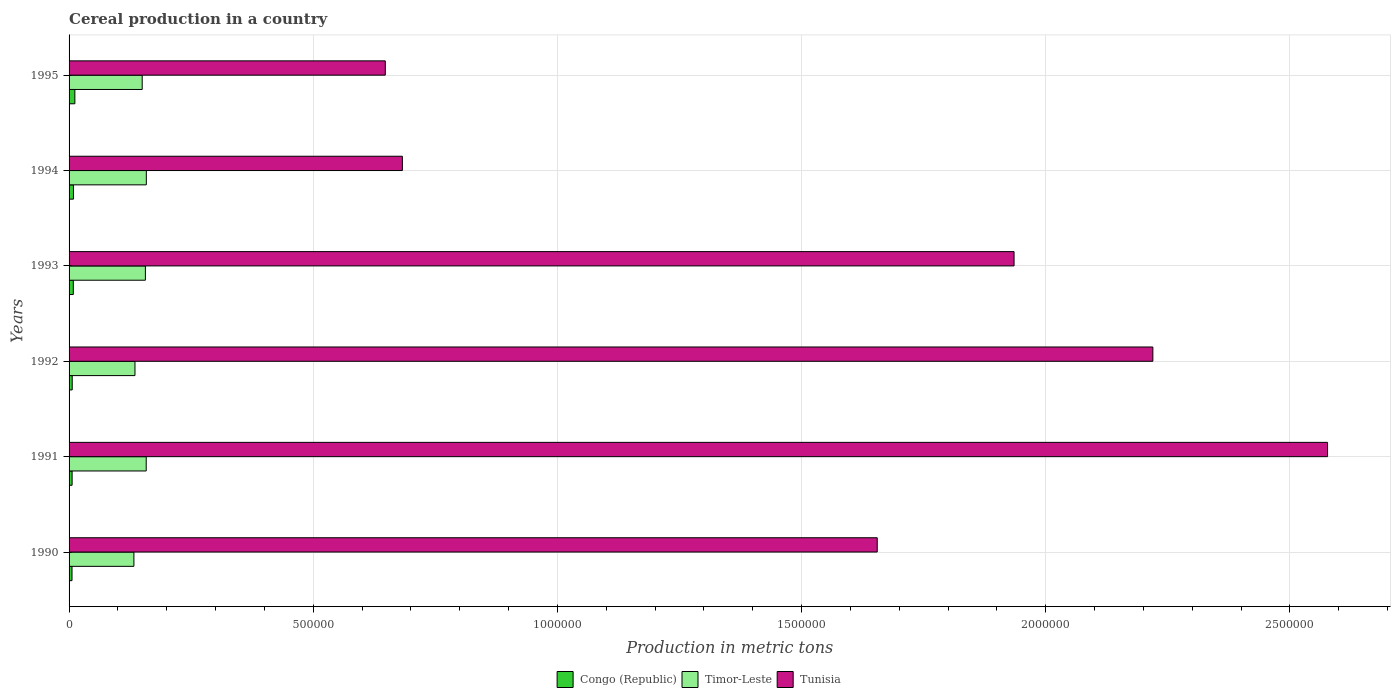Are the number of bars per tick equal to the number of legend labels?
Make the answer very short. Yes. Are the number of bars on each tick of the Y-axis equal?
Make the answer very short. Yes. How many bars are there on the 1st tick from the bottom?
Provide a short and direct response. 3. What is the label of the 6th group of bars from the top?
Ensure brevity in your answer.  1990. What is the total cereal production in Congo (Republic) in 1993?
Give a very brief answer. 8663. Across all years, what is the maximum total cereal production in Timor-Leste?
Your answer should be compact. 1.58e+05. Across all years, what is the minimum total cereal production in Congo (Republic)?
Make the answer very short. 6014. In which year was the total cereal production in Timor-Leste maximum?
Provide a succinct answer. 1994. In which year was the total cereal production in Timor-Leste minimum?
Give a very brief answer. 1990. What is the total total cereal production in Timor-Leste in the graph?
Give a very brief answer. 8.90e+05. What is the difference between the total cereal production in Timor-Leste in 1990 and that in 1991?
Make the answer very short. -2.52e+04. What is the difference between the total cereal production in Timor-Leste in 1992 and the total cereal production in Tunisia in 1995?
Make the answer very short. -5.13e+05. What is the average total cereal production in Timor-Leste per year?
Keep it short and to the point. 1.48e+05. In the year 1992, what is the difference between the total cereal production in Tunisia and total cereal production in Timor-Leste?
Your response must be concise. 2.08e+06. In how many years, is the total cereal production in Congo (Republic) greater than 400000 metric tons?
Ensure brevity in your answer.  0. What is the ratio of the total cereal production in Congo (Republic) in 1991 to that in 1994?
Offer a terse response. 0.69. Is the difference between the total cereal production in Tunisia in 1990 and 1991 greater than the difference between the total cereal production in Timor-Leste in 1990 and 1991?
Offer a terse response. No. What is the difference between the highest and the second highest total cereal production in Tunisia?
Provide a short and direct response. 3.58e+05. What is the difference between the highest and the lowest total cereal production in Tunisia?
Provide a short and direct response. 1.93e+06. Is the sum of the total cereal production in Congo (Republic) in 1990 and 1995 greater than the maximum total cereal production in Tunisia across all years?
Provide a succinct answer. No. What does the 1st bar from the top in 1993 represents?
Offer a very short reply. Tunisia. What does the 3rd bar from the bottom in 1990 represents?
Your response must be concise. Tunisia. Are the values on the major ticks of X-axis written in scientific E-notation?
Keep it short and to the point. No. Does the graph contain any zero values?
Your answer should be compact. No. Does the graph contain grids?
Make the answer very short. Yes. How are the legend labels stacked?
Offer a terse response. Horizontal. What is the title of the graph?
Ensure brevity in your answer.  Cereal production in a country. Does "Tonga" appear as one of the legend labels in the graph?
Provide a succinct answer. No. What is the label or title of the X-axis?
Ensure brevity in your answer.  Production in metric tons. What is the Production in metric tons of Congo (Republic) in 1990?
Keep it short and to the point. 6014. What is the Production in metric tons of Timor-Leste in 1990?
Provide a short and direct response. 1.33e+05. What is the Production in metric tons of Tunisia in 1990?
Provide a succinct answer. 1.65e+06. What is the Production in metric tons of Congo (Republic) in 1991?
Your answer should be compact. 6225. What is the Production in metric tons in Timor-Leste in 1991?
Provide a succinct answer. 1.58e+05. What is the Production in metric tons of Tunisia in 1991?
Give a very brief answer. 2.58e+06. What is the Production in metric tons of Congo (Republic) in 1992?
Your response must be concise. 6442. What is the Production in metric tons of Timor-Leste in 1992?
Keep it short and to the point. 1.35e+05. What is the Production in metric tons in Tunisia in 1992?
Make the answer very short. 2.22e+06. What is the Production in metric tons in Congo (Republic) in 1993?
Provide a short and direct response. 8663. What is the Production in metric tons of Timor-Leste in 1993?
Make the answer very short. 1.56e+05. What is the Production in metric tons of Tunisia in 1993?
Offer a very short reply. 1.94e+06. What is the Production in metric tons in Congo (Republic) in 1994?
Provide a succinct answer. 8967. What is the Production in metric tons in Timor-Leste in 1994?
Offer a very short reply. 1.58e+05. What is the Production in metric tons of Tunisia in 1994?
Ensure brevity in your answer.  6.82e+05. What is the Production in metric tons in Congo (Republic) in 1995?
Make the answer very short. 1.18e+04. What is the Production in metric tons in Timor-Leste in 1995?
Your answer should be very brief. 1.50e+05. What is the Production in metric tons in Tunisia in 1995?
Provide a short and direct response. 6.48e+05. Across all years, what is the maximum Production in metric tons in Congo (Republic)?
Offer a terse response. 1.18e+04. Across all years, what is the maximum Production in metric tons in Timor-Leste?
Make the answer very short. 1.58e+05. Across all years, what is the maximum Production in metric tons in Tunisia?
Your response must be concise. 2.58e+06. Across all years, what is the minimum Production in metric tons of Congo (Republic)?
Provide a succinct answer. 6014. Across all years, what is the minimum Production in metric tons of Timor-Leste?
Your answer should be very brief. 1.33e+05. Across all years, what is the minimum Production in metric tons of Tunisia?
Offer a very short reply. 6.48e+05. What is the total Production in metric tons of Congo (Republic) in the graph?
Provide a succinct answer. 4.82e+04. What is the total Production in metric tons of Timor-Leste in the graph?
Your answer should be very brief. 8.90e+05. What is the total Production in metric tons of Tunisia in the graph?
Give a very brief answer. 9.72e+06. What is the difference between the Production in metric tons of Congo (Republic) in 1990 and that in 1991?
Offer a terse response. -211. What is the difference between the Production in metric tons of Timor-Leste in 1990 and that in 1991?
Your answer should be compact. -2.52e+04. What is the difference between the Production in metric tons in Tunisia in 1990 and that in 1991?
Ensure brevity in your answer.  -9.22e+05. What is the difference between the Production in metric tons in Congo (Republic) in 1990 and that in 1992?
Offer a terse response. -428. What is the difference between the Production in metric tons in Timor-Leste in 1990 and that in 1992?
Ensure brevity in your answer.  -2167. What is the difference between the Production in metric tons of Tunisia in 1990 and that in 1992?
Your answer should be compact. -5.64e+05. What is the difference between the Production in metric tons in Congo (Republic) in 1990 and that in 1993?
Your response must be concise. -2649. What is the difference between the Production in metric tons in Timor-Leste in 1990 and that in 1993?
Provide a succinct answer. -2.35e+04. What is the difference between the Production in metric tons of Tunisia in 1990 and that in 1993?
Offer a very short reply. -2.80e+05. What is the difference between the Production in metric tons of Congo (Republic) in 1990 and that in 1994?
Your answer should be compact. -2953. What is the difference between the Production in metric tons in Timor-Leste in 1990 and that in 1994?
Make the answer very short. -2.54e+04. What is the difference between the Production in metric tons of Tunisia in 1990 and that in 1994?
Your answer should be very brief. 9.72e+05. What is the difference between the Production in metric tons in Congo (Republic) in 1990 and that in 1995?
Ensure brevity in your answer.  -5835. What is the difference between the Production in metric tons in Timor-Leste in 1990 and that in 1995?
Give a very brief answer. -1.70e+04. What is the difference between the Production in metric tons in Tunisia in 1990 and that in 1995?
Your answer should be very brief. 1.01e+06. What is the difference between the Production in metric tons of Congo (Republic) in 1991 and that in 1992?
Your answer should be very brief. -217. What is the difference between the Production in metric tons of Timor-Leste in 1991 and that in 1992?
Give a very brief answer. 2.30e+04. What is the difference between the Production in metric tons in Tunisia in 1991 and that in 1992?
Give a very brief answer. 3.58e+05. What is the difference between the Production in metric tons of Congo (Republic) in 1991 and that in 1993?
Provide a succinct answer. -2438. What is the difference between the Production in metric tons in Timor-Leste in 1991 and that in 1993?
Provide a short and direct response. 1677. What is the difference between the Production in metric tons of Tunisia in 1991 and that in 1993?
Keep it short and to the point. 6.42e+05. What is the difference between the Production in metric tons of Congo (Republic) in 1991 and that in 1994?
Provide a succinct answer. -2742. What is the difference between the Production in metric tons of Timor-Leste in 1991 and that in 1994?
Your answer should be very brief. -234. What is the difference between the Production in metric tons of Tunisia in 1991 and that in 1994?
Your response must be concise. 1.89e+06. What is the difference between the Production in metric tons of Congo (Republic) in 1991 and that in 1995?
Offer a very short reply. -5624. What is the difference between the Production in metric tons in Timor-Leste in 1991 and that in 1995?
Your answer should be compact. 8231. What is the difference between the Production in metric tons of Tunisia in 1991 and that in 1995?
Offer a very short reply. 1.93e+06. What is the difference between the Production in metric tons in Congo (Republic) in 1992 and that in 1993?
Offer a terse response. -2221. What is the difference between the Production in metric tons in Timor-Leste in 1992 and that in 1993?
Give a very brief answer. -2.14e+04. What is the difference between the Production in metric tons of Tunisia in 1992 and that in 1993?
Ensure brevity in your answer.  2.84e+05. What is the difference between the Production in metric tons in Congo (Republic) in 1992 and that in 1994?
Make the answer very short. -2525. What is the difference between the Production in metric tons in Timor-Leste in 1992 and that in 1994?
Your response must be concise. -2.33e+04. What is the difference between the Production in metric tons of Tunisia in 1992 and that in 1994?
Make the answer very short. 1.54e+06. What is the difference between the Production in metric tons in Congo (Republic) in 1992 and that in 1995?
Your response must be concise. -5407. What is the difference between the Production in metric tons of Timor-Leste in 1992 and that in 1995?
Keep it short and to the point. -1.48e+04. What is the difference between the Production in metric tons in Tunisia in 1992 and that in 1995?
Provide a short and direct response. 1.57e+06. What is the difference between the Production in metric tons in Congo (Republic) in 1993 and that in 1994?
Offer a terse response. -304. What is the difference between the Production in metric tons of Timor-Leste in 1993 and that in 1994?
Give a very brief answer. -1911. What is the difference between the Production in metric tons in Tunisia in 1993 and that in 1994?
Keep it short and to the point. 1.25e+06. What is the difference between the Production in metric tons of Congo (Republic) in 1993 and that in 1995?
Your answer should be very brief. -3186. What is the difference between the Production in metric tons in Timor-Leste in 1993 and that in 1995?
Your response must be concise. 6554. What is the difference between the Production in metric tons in Tunisia in 1993 and that in 1995?
Your response must be concise. 1.29e+06. What is the difference between the Production in metric tons of Congo (Republic) in 1994 and that in 1995?
Provide a succinct answer. -2882. What is the difference between the Production in metric tons in Timor-Leste in 1994 and that in 1995?
Offer a terse response. 8465. What is the difference between the Production in metric tons in Tunisia in 1994 and that in 1995?
Give a very brief answer. 3.50e+04. What is the difference between the Production in metric tons of Congo (Republic) in 1990 and the Production in metric tons of Timor-Leste in 1991?
Give a very brief answer. -1.52e+05. What is the difference between the Production in metric tons of Congo (Republic) in 1990 and the Production in metric tons of Tunisia in 1991?
Ensure brevity in your answer.  -2.57e+06. What is the difference between the Production in metric tons in Timor-Leste in 1990 and the Production in metric tons in Tunisia in 1991?
Your response must be concise. -2.44e+06. What is the difference between the Production in metric tons in Congo (Republic) in 1990 and the Production in metric tons in Timor-Leste in 1992?
Provide a succinct answer. -1.29e+05. What is the difference between the Production in metric tons in Congo (Republic) in 1990 and the Production in metric tons in Tunisia in 1992?
Ensure brevity in your answer.  -2.21e+06. What is the difference between the Production in metric tons in Timor-Leste in 1990 and the Production in metric tons in Tunisia in 1992?
Keep it short and to the point. -2.09e+06. What is the difference between the Production in metric tons in Congo (Republic) in 1990 and the Production in metric tons in Timor-Leste in 1993?
Keep it short and to the point. -1.50e+05. What is the difference between the Production in metric tons of Congo (Republic) in 1990 and the Production in metric tons of Tunisia in 1993?
Ensure brevity in your answer.  -1.93e+06. What is the difference between the Production in metric tons of Timor-Leste in 1990 and the Production in metric tons of Tunisia in 1993?
Ensure brevity in your answer.  -1.80e+06. What is the difference between the Production in metric tons in Congo (Republic) in 1990 and the Production in metric tons in Timor-Leste in 1994?
Give a very brief answer. -1.52e+05. What is the difference between the Production in metric tons of Congo (Republic) in 1990 and the Production in metric tons of Tunisia in 1994?
Provide a short and direct response. -6.76e+05. What is the difference between the Production in metric tons of Timor-Leste in 1990 and the Production in metric tons of Tunisia in 1994?
Give a very brief answer. -5.50e+05. What is the difference between the Production in metric tons of Congo (Republic) in 1990 and the Production in metric tons of Timor-Leste in 1995?
Offer a very short reply. -1.44e+05. What is the difference between the Production in metric tons of Congo (Republic) in 1990 and the Production in metric tons of Tunisia in 1995?
Offer a very short reply. -6.42e+05. What is the difference between the Production in metric tons of Timor-Leste in 1990 and the Production in metric tons of Tunisia in 1995?
Provide a short and direct response. -5.15e+05. What is the difference between the Production in metric tons of Congo (Republic) in 1991 and the Production in metric tons of Timor-Leste in 1992?
Make the answer very short. -1.29e+05. What is the difference between the Production in metric tons of Congo (Republic) in 1991 and the Production in metric tons of Tunisia in 1992?
Keep it short and to the point. -2.21e+06. What is the difference between the Production in metric tons of Timor-Leste in 1991 and the Production in metric tons of Tunisia in 1992?
Your response must be concise. -2.06e+06. What is the difference between the Production in metric tons in Congo (Republic) in 1991 and the Production in metric tons in Timor-Leste in 1993?
Offer a very short reply. -1.50e+05. What is the difference between the Production in metric tons in Congo (Republic) in 1991 and the Production in metric tons in Tunisia in 1993?
Keep it short and to the point. -1.93e+06. What is the difference between the Production in metric tons of Timor-Leste in 1991 and the Production in metric tons of Tunisia in 1993?
Give a very brief answer. -1.78e+06. What is the difference between the Production in metric tons of Congo (Republic) in 1991 and the Production in metric tons of Timor-Leste in 1994?
Provide a succinct answer. -1.52e+05. What is the difference between the Production in metric tons of Congo (Republic) in 1991 and the Production in metric tons of Tunisia in 1994?
Offer a very short reply. -6.76e+05. What is the difference between the Production in metric tons in Timor-Leste in 1991 and the Production in metric tons in Tunisia in 1994?
Offer a very short reply. -5.25e+05. What is the difference between the Production in metric tons of Congo (Republic) in 1991 and the Production in metric tons of Timor-Leste in 1995?
Provide a short and direct response. -1.44e+05. What is the difference between the Production in metric tons in Congo (Republic) in 1991 and the Production in metric tons in Tunisia in 1995?
Make the answer very short. -6.41e+05. What is the difference between the Production in metric tons in Timor-Leste in 1991 and the Production in metric tons in Tunisia in 1995?
Make the answer very short. -4.90e+05. What is the difference between the Production in metric tons of Congo (Republic) in 1992 and the Production in metric tons of Timor-Leste in 1993?
Offer a very short reply. -1.50e+05. What is the difference between the Production in metric tons in Congo (Republic) in 1992 and the Production in metric tons in Tunisia in 1993?
Offer a terse response. -1.93e+06. What is the difference between the Production in metric tons of Timor-Leste in 1992 and the Production in metric tons of Tunisia in 1993?
Provide a short and direct response. -1.80e+06. What is the difference between the Production in metric tons of Congo (Republic) in 1992 and the Production in metric tons of Timor-Leste in 1994?
Your response must be concise. -1.52e+05. What is the difference between the Production in metric tons in Congo (Republic) in 1992 and the Production in metric tons in Tunisia in 1994?
Provide a succinct answer. -6.76e+05. What is the difference between the Production in metric tons in Timor-Leste in 1992 and the Production in metric tons in Tunisia in 1994?
Make the answer very short. -5.48e+05. What is the difference between the Production in metric tons in Congo (Republic) in 1992 and the Production in metric tons in Timor-Leste in 1995?
Give a very brief answer. -1.43e+05. What is the difference between the Production in metric tons of Congo (Republic) in 1992 and the Production in metric tons of Tunisia in 1995?
Offer a very short reply. -6.41e+05. What is the difference between the Production in metric tons in Timor-Leste in 1992 and the Production in metric tons in Tunisia in 1995?
Provide a short and direct response. -5.13e+05. What is the difference between the Production in metric tons in Congo (Republic) in 1993 and the Production in metric tons in Timor-Leste in 1994?
Ensure brevity in your answer.  -1.50e+05. What is the difference between the Production in metric tons in Congo (Republic) in 1993 and the Production in metric tons in Tunisia in 1994?
Offer a terse response. -6.74e+05. What is the difference between the Production in metric tons in Timor-Leste in 1993 and the Production in metric tons in Tunisia in 1994?
Your response must be concise. -5.26e+05. What is the difference between the Production in metric tons in Congo (Republic) in 1993 and the Production in metric tons in Timor-Leste in 1995?
Provide a short and direct response. -1.41e+05. What is the difference between the Production in metric tons in Congo (Republic) in 1993 and the Production in metric tons in Tunisia in 1995?
Offer a terse response. -6.39e+05. What is the difference between the Production in metric tons of Timor-Leste in 1993 and the Production in metric tons of Tunisia in 1995?
Your answer should be very brief. -4.91e+05. What is the difference between the Production in metric tons in Congo (Republic) in 1994 and the Production in metric tons in Timor-Leste in 1995?
Make the answer very short. -1.41e+05. What is the difference between the Production in metric tons in Congo (Republic) in 1994 and the Production in metric tons in Tunisia in 1995?
Keep it short and to the point. -6.39e+05. What is the difference between the Production in metric tons of Timor-Leste in 1994 and the Production in metric tons of Tunisia in 1995?
Make the answer very short. -4.89e+05. What is the average Production in metric tons in Congo (Republic) per year?
Ensure brevity in your answer.  8026.67. What is the average Production in metric tons of Timor-Leste per year?
Your response must be concise. 1.48e+05. What is the average Production in metric tons of Tunisia per year?
Offer a terse response. 1.62e+06. In the year 1990, what is the difference between the Production in metric tons of Congo (Republic) and Production in metric tons of Timor-Leste?
Give a very brief answer. -1.27e+05. In the year 1990, what is the difference between the Production in metric tons in Congo (Republic) and Production in metric tons in Tunisia?
Make the answer very short. -1.65e+06. In the year 1990, what is the difference between the Production in metric tons of Timor-Leste and Production in metric tons of Tunisia?
Provide a short and direct response. -1.52e+06. In the year 1991, what is the difference between the Production in metric tons of Congo (Republic) and Production in metric tons of Timor-Leste?
Give a very brief answer. -1.52e+05. In the year 1991, what is the difference between the Production in metric tons of Congo (Republic) and Production in metric tons of Tunisia?
Your response must be concise. -2.57e+06. In the year 1991, what is the difference between the Production in metric tons in Timor-Leste and Production in metric tons in Tunisia?
Keep it short and to the point. -2.42e+06. In the year 1992, what is the difference between the Production in metric tons of Congo (Republic) and Production in metric tons of Timor-Leste?
Your answer should be compact. -1.28e+05. In the year 1992, what is the difference between the Production in metric tons in Congo (Republic) and Production in metric tons in Tunisia?
Make the answer very short. -2.21e+06. In the year 1992, what is the difference between the Production in metric tons in Timor-Leste and Production in metric tons in Tunisia?
Provide a succinct answer. -2.08e+06. In the year 1993, what is the difference between the Production in metric tons in Congo (Republic) and Production in metric tons in Timor-Leste?
Ensure brevity in your answer.  -1.48e+05. In the year 1993, what is the difference between the Production in metric tons of Congo (Republic) and Production in metric tons of Tunisia?
Give a very brief answer. -1.93e+06. In the year 1993, what is the difference between the Production in metric tons in Timor-Leste and Production in metric tons in Tunisia?
Keep it short and to the point. -1.78e+06. In the year 1994, what is the difference between the Production in metric tons in Congo (Republic) and Production in metric tons in Timor-Leste?
Make the answer very short. -1.49e+05. In the year 1994, what is the difference between the Production in metric tons in Congo (Republic) and Production in metric tons in Tunisia?
Make the answer very short. -6.74e+05. In the year 1994, what is the difference between the Production in metric tons in Timor-Leste and Production in metric tons in Tunisia?
Your answer should be compact. -5.24e+05. In the year 1995, what is the difference between the Production in metric tons in Congo (Republic) and Production in metric tons in Timor-Leste?
Offer a terse response. -1.38e+05. In the year 1995, what is the difference between the Production in metric tons in Congo (Republic) and Production in metric tons in Tunisia?
Provide a short and direct response. -6.36e+05. In the year 1995, what is the difference between the Production in metric tons in Timor-Leste and Production in metric tons in Tunisia?
Your response must be concise. -4.98e+05. What is the ratio of the Production in metric tons in Congo (Republic) in 1990 to that in 1991?
Provide a short and direct response. 0.97. What is the ratio of the Production in metric tons in Timor-Leste in 1990 to that in 1991?
Keep it short and to the point. 0.84. What is the ratio of the Production in metric tons in Tunisia in 1990 to that in 1991?
Offer a very short reply. 0.64. What is the ratio of the Production in metric tons of Congo (Republic) in 1990 to that in 1992?
Your response must be concise. 0.93. What is the ratio of the Production in metric tons in Timor-Leste in 1990 to that in 1992?
Provide a succinct answer. 0.98. What is the ratio of the Production in metric tons in Tunisia in 1990 to that in 1992?
Keep it short and to the point. 0.75. What is the ratio of the Production in metric tons in Congo (Republic) in 1990 to that in 1993?
Keep it short and to the point. 0.69. What is the ratio of the Production in metric tons in Timor-Leste in 1990 to that in 1993?
Ensure brevity in your answer.  0.85. What is the ratio of the Production in metric tons of Tunisia in 1990 to that in 1993?
Provide a succinct answer. 0.86. What is the ratio of the Production in metric tons in Congo (Republic) in 1990 to that in 1994?
Your answer should be very brief. 0.67. What is the ratio of the Production in metric tons in Timor-Leste in 1990 to that in 1994?
Provide a short and direct response. 0.84. What is the ratio of the Production in metric tons in Tunisia in 1990 to that in 1994?
Your response must be concise. 2.42. What is the ratio of the Production in metric tons in Congo (Republic) in 1990 to that in 1995?
Provide a succinct answer. 0.51. What is the ratio of the Production in metric tons in Timor-Leste in 1990 to that in 1995?
Your response must be concise. 0.89. What is the ratio of the Production in metric tons in Tunisia in 1990 to that in 1995?
Provide a short and direct response. 2.56. What is the ratio of the Production in metric tons in Congo (Republic) in 1991 to that in 1992?
Your answer should be compact. 0.97. What is the ratio of the Production in metric tons of Timor-Leste in 1991 to that in 1992?
Offer a very short reply. 1.17. What is the ratio of the Production in metric tons in Tunisia in 1991 to that in 1992?
Give a very brief answer. 1.16. What is the ratio of the Production in metric tons in Congo (Republic) in 1991 to that in 1993?
Your answer should be compact. 0.72. What is the ratio of the Production in metric tons of Timor-Leste in 1991 to that in 1993?
Make the answer very short. 1.01. What is the ratio of the Production in metric tons in Tunisia in 1991 to that in 1993?
Your answer should be very brief. 1.33. What is the ratio of the Production in metric tons in Congo (Republic) in 1991 to that in 1994?
Provide a succinct answer. 0.69. What is the ratio of the Production in metric tons of Tunisia in 1991 to that in 1994?
Make the answer very short. 3.78. What is the ratio of the Production in metric tons in Congo (Republic) in 1991 to that in 1995?
Keep it short and to the point. 0.53. What is the ratio of the Production in metric tons in Timor-Leste in 1991 to that in 1995?
Your response must be concise. 1.05. What is the ratio of the Production in metric tons in Tunisia in 1991 to that in 1995?
Ensure brevity in your answer.  3.98. What is the ratio of the Production in metric tons in Congo (Republic) in 1992 to that in 1993?
Give a very brief answer. 0.74. What is the ratio of the Production in metric tons of Timor-Leste in 1992 to that in 1993?
Keep it short and to the point. 0.86. What is the ratio of the Production in metric tons in Tunisia in 1992 to that in 1993?
Give a very brief answer. 1.15. What is the ratio of the Production in metric tons of Congo (Republic) in 1992 to that in 1994?
Ensure brevity in your answer.  0.72. What is the ratio of the Production in metric tons of Timor-Leste in 1992 to that in 1994?
Your answer should be compact. 0.85. What is the ratio of the Production in metric tons in Tunisia in 1992 to that in 1994?
Offer a very short reply. 3.25. What is the ratio of the Production in metric tons in Congo (Republic) in 1992 to that in 1995?
Offer a very short reply. 0.54. What is the ratio of the Production in metric tons in Timor-Leste in 1992 to that in 1995?
Your response must be concise. 0.9. What is the ratio of the Production in metric tons of Tunisia in 1992 to that in 1995?
Ensure brevity in your answer.  3.43. What is the ratio of the Production in metric tons in Congo (Republic) in 1993 to that in 1994?
Your answer should be compact. 0.97. What is the ratio of the Production in metric tons in Timor-Leste in 1993 to that in 1994?
Keep it short and to the point. 0.99. What is the ratio of the Production in metric tons of Tunisia in 1993 to that in 1994?
Your response must be concise. 2.84. What is the ratio of the Production in metric tons of Congo (Republic) in 1993 to that in 1995?
Offer a terse response. 0.73. What is the ratio of the Production in metric tons in Timor-Leste in 1993 to that in 1995?
Provide a succinct answer. 1.04. What is the ratio of the Production in metric tons in Tunisia in 1993 to that in 1995?
Your response must be concise. 2.99. What is the ratio of the Production in metric tons in Congo (Republic) in 1994 to that in 1995?
Your answer should be compact. 0.76. What is the ratio of the Production in metric tons in Timor-Leste in 1994 to that in 1995?
Provide a succinct answer. 1.06. What is the ratio of the Production in metric tons in Tunisia in 1994 to that in 1995?
Keep it short and to the point. 1.05. What is the difference between the highest and the second highest Production in metric tons of Congo (Republic)?
Give a very brief answer. 2882. What is the difference between the highest and the second highest Production in metric tons in Timor-Leste?
Provide a succinct answer. 234. What is the difference between the highest and the second highest Production in metric tons in Tunisia?
Your answer should be very brief. 3.58e+05. What is the difference between the highest and the lowest Production in metric tons in Congo (Republic)?
Your response must be concise. 5835. What is the difference between the highest and the lowest Production in metric tons of Timor-Leste?
Keep it short and to the point. 2.54e+04. What is the difference between the highest and the lowest Production in metric tons in Tunisia?
Give a very brief answer. 1.93e+06. 